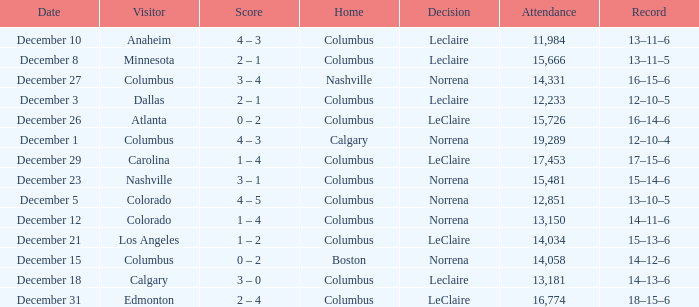What was the score with a 16–14–6 record? 0 – 2. 